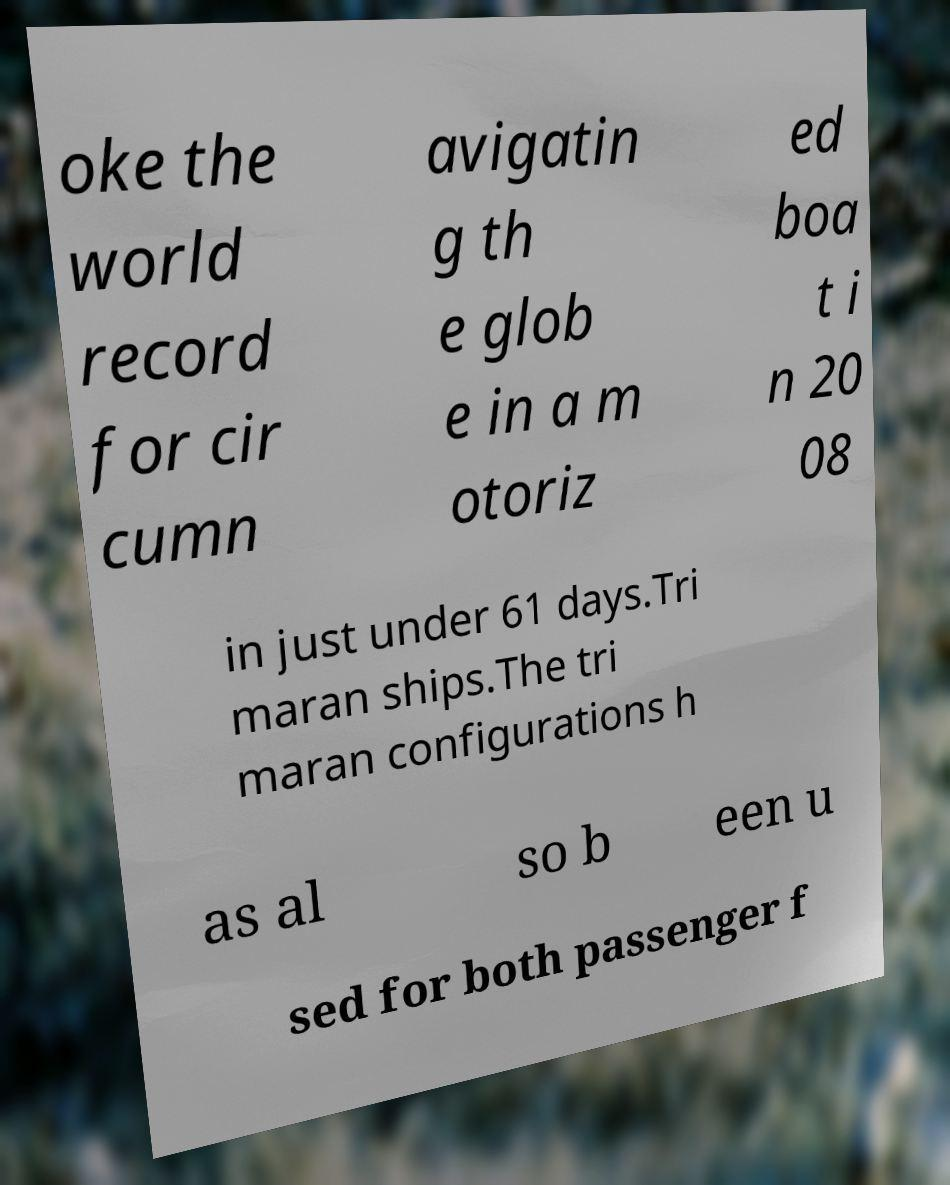I need the written content from this picture converted into text. Can you do that? oke the world record for cir cumn avigatin g th e glob e in a m otoriz ed boa t i n 20 08 in just under 61 days.Tri maran ships.The tri maran configurations h as al so b een u sed for both passenger f 